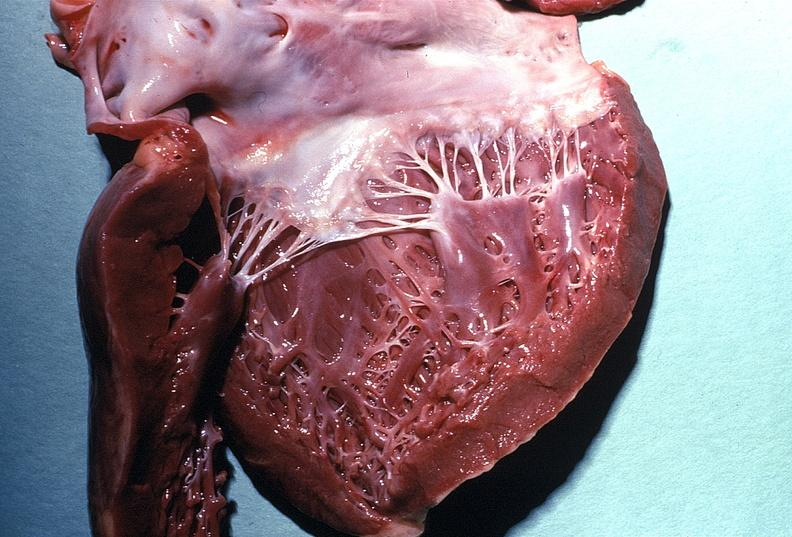s cardiovascular present?
Answer the question using a single word or phrase. Yes 